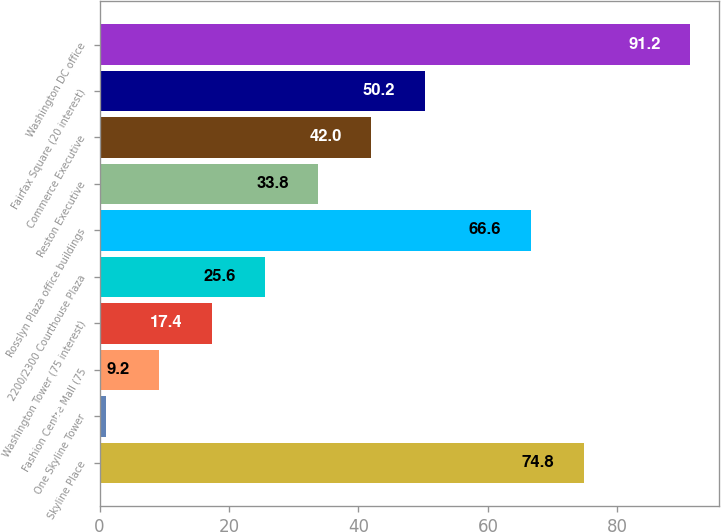Convert chart to OTSL. <chart><loc_0><loc_0><loc_500><loc_500><bar_chart><fcel>Skyline Place<fcel>One Skyline Tower<fcel>Fashion Centre Mall (75<fcel>Washington Tower (75 interest)<fcel>2200/2300 Courthouse Plaza<fcel>Rosslyn Plaza office buildings<fcel>Reston Executive<fcel>Commerce Executive<fcel>Fairfax Square (20 interest)<fcel>Washington DC office<nl><fcel>74.8<fcel>1<fcel>9.2<fcel>17.4<fcel>25.6<fcel>66.6<fcel>33.8<fcel>42<fcel>50.2<fcel>91.2<nl></chart> 